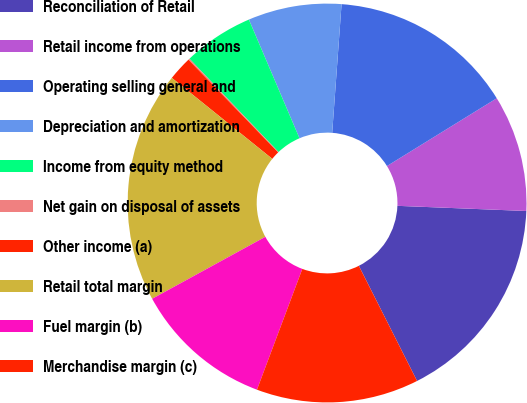Convert chart. <chart><loc_0><loc_0><loc_500><loc_500><pie_chart><fcel>Reconciliation of Retail<fcel>Retail income from operations<fcel>Operating selling general and<fcel>Depreciation and amortization<fcel>Income from equity method<fcel>Net gain on disposal of assets<fcel>Other income (a)<fcel>Retail total margin<fcel>Fuel margin (b)<fcel>Merchandise margin (c)<nl><fcel>16.91%<fcel>9.44%<fcel>15.04%<fcel>7.57%<fcel>5.71%<fcel>0.11%<fcel>1.97%<fcel>18.77%<fcel>11.31%<fcel>13.17%<nl></chart> 